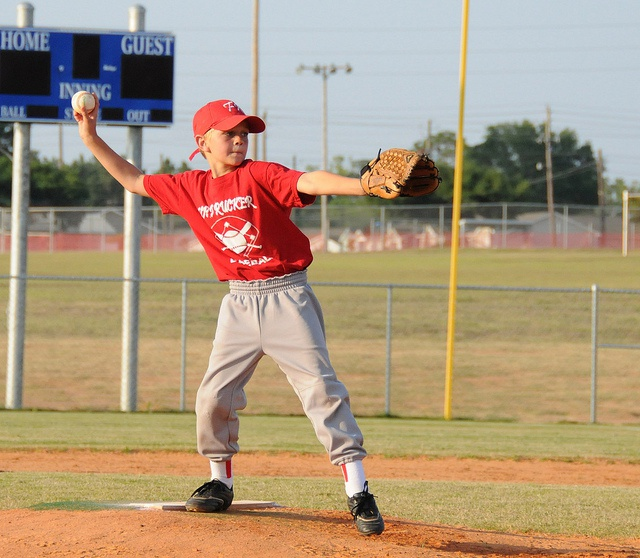Describe the objects in this image and their specific colors. I can see people in lightgray, tan, and red tones, baseball glove in lightgray, black, tan, maroon, and brown tones, and sports ball in lightgray, beige, darkgray, and tan tones in this image. 